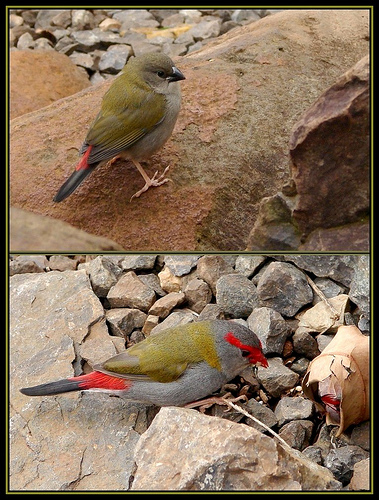<image>What type of bird is this? I don't know what type of bird this is. It could be a finch, sparrow, robin, wren, or goldfinch. What type of bird is this? I don't know what type of bird is this. It can be 'finch', 'little 1', 'sparrow', 'exotic bird', 'robin', 'wren' or 'goldfinch'. 